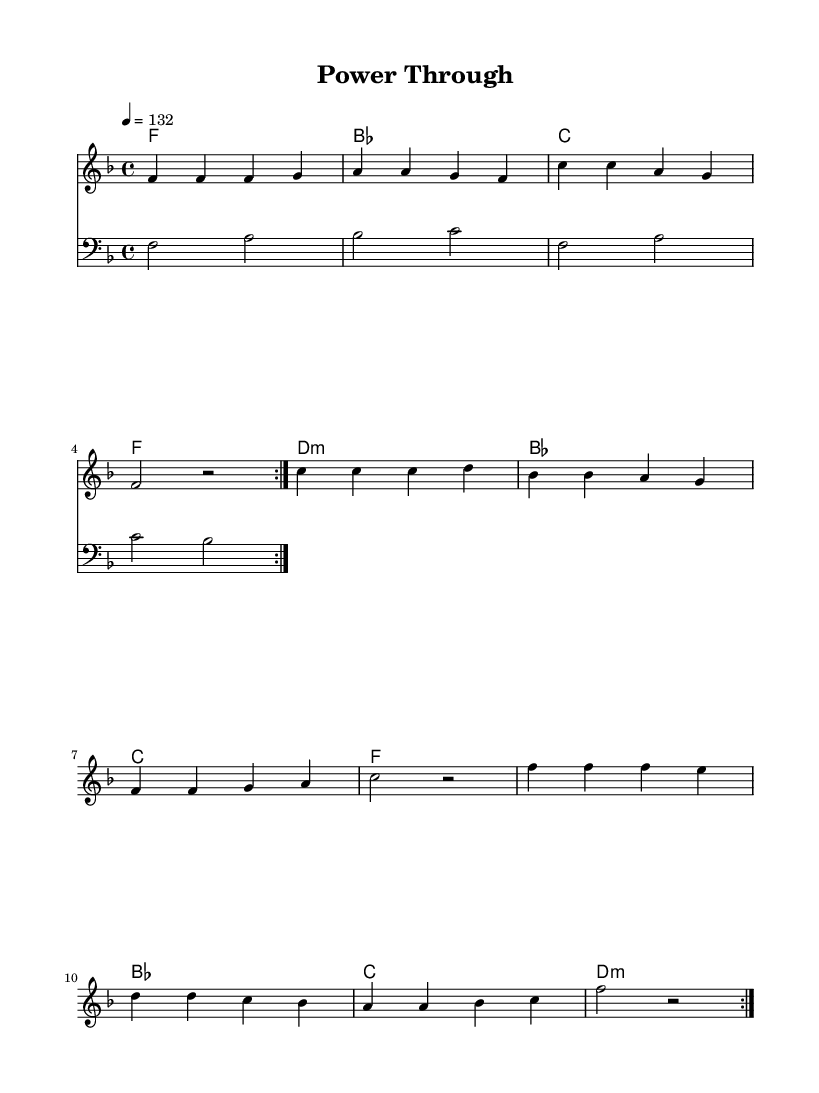What is the key signature of this music? The key signature is indicated by the absence of any sharps or flats, meaning it is in F major, which has one flat (B flat).
Answer: F major What is the time signature of this music? The time signature is indicated at the beginning of the sheet music as 4/4, meaning there are four beats in a measure and the quarter note receives one beat.
Answer: 4/4 What is the tempo marking for this piece? The tempo marking in the sheet music indicates a tempo of 132 beats per minute, which means the music is meant to be played at a fairly quick pace.
Answer: 132 How many measures are there in the repeating section? The repeating section consists of two repeats of twelve measures as indicated by the repeat signs.
Answer: 12 What is the primary genre of this music? The structure and rhythmic feel of the piece, along with the lyrics, indicate that this is a Disco anthem meant for high-energy and motivational contexts, typical of dance-oriented music.
Answer: Disco What type of chords are used in the harmonies? The harmonies include major chords (F, B flat, C, D minor) indicating a mix of happiness and drive, typical in Disco music for motivating rhythms.
Answer: Major and minor chords What is the lyrical theme of this song? The lyrics focus on overcoming challenges and personal strength, emphasizing the message of power and endurance during workouts, which is a common theme in athletic motivational music.
Answer: Power and endurance 